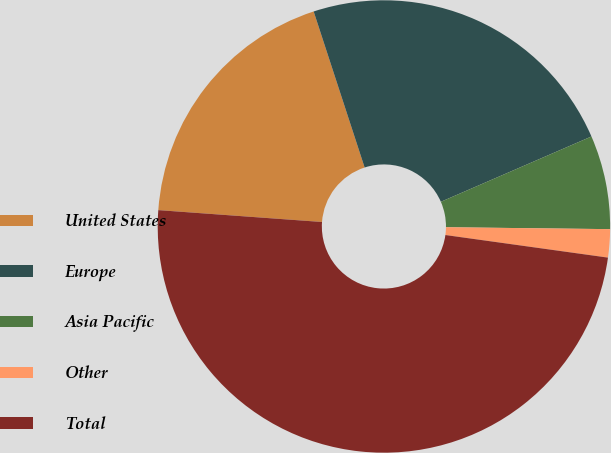<chart> <loc_0><loc_0><loc_500><loc_500><pie_chart><fcel>United States<fcel>Europe<fcel>Asia Pacific<fcel>Other<fcel>Total<nl><fcel>18.82%<fcel>23.51%<fcel>6.7%<fcel>2.01%<fcel>48.95%<nl></chart> 